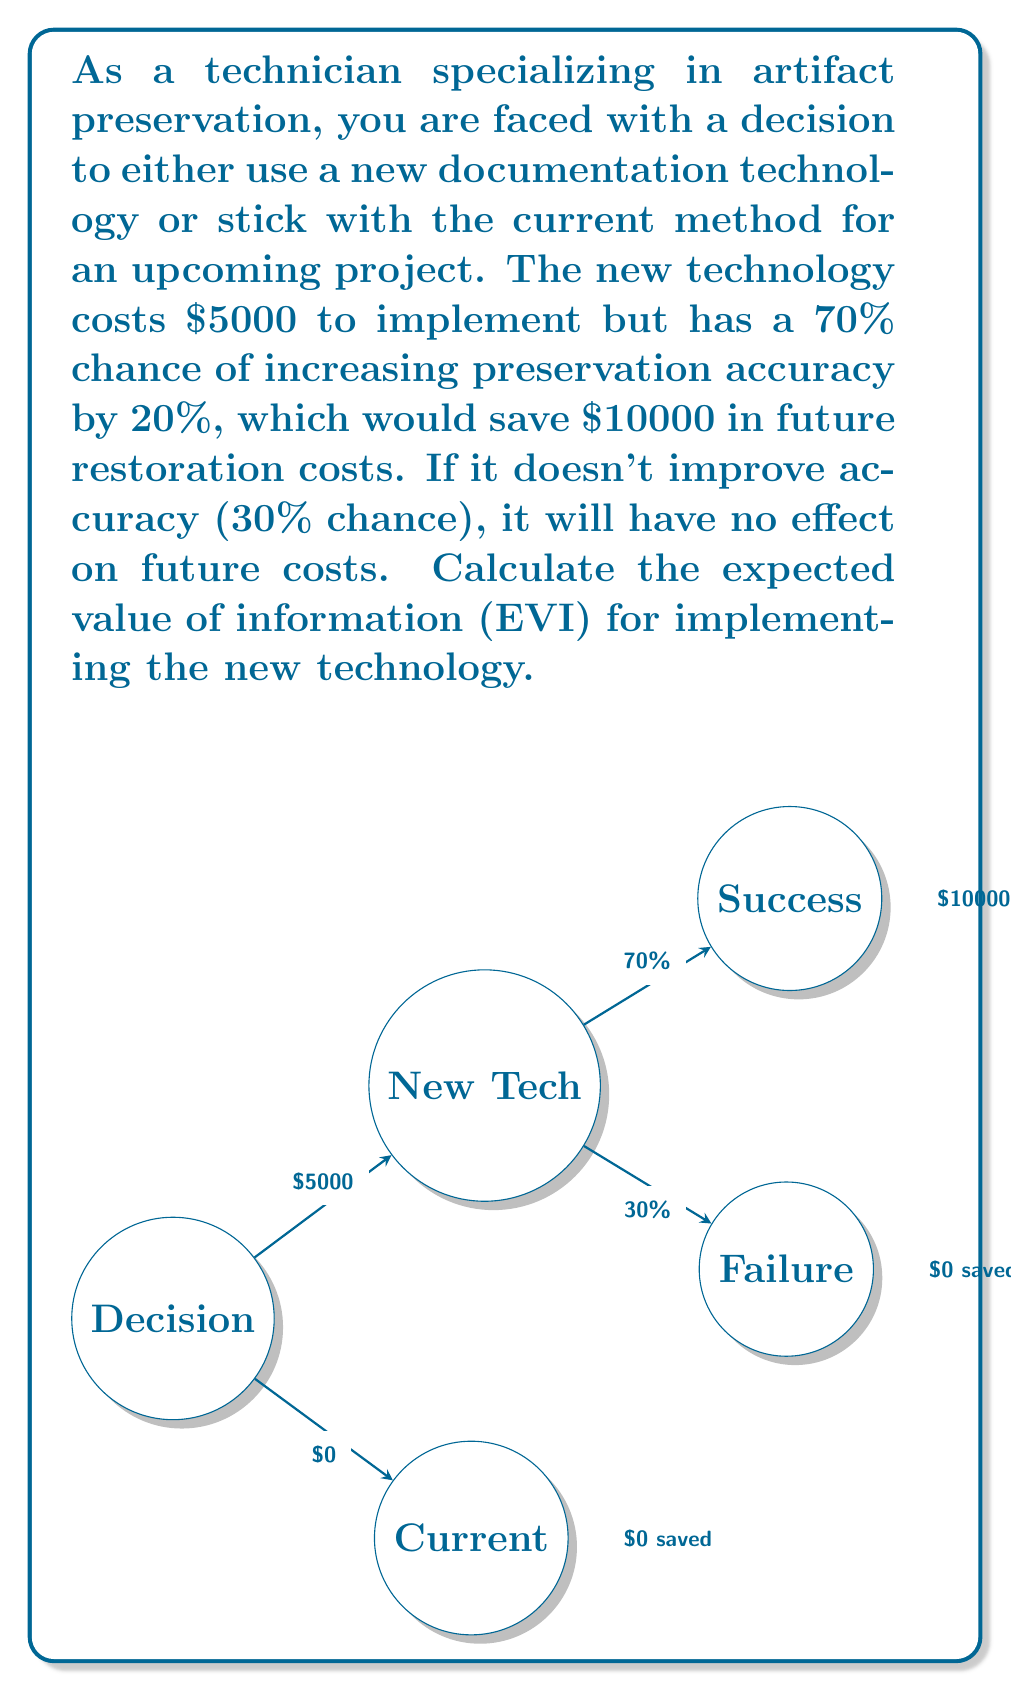Help me with this question. To calculate the Expected Value of Information (EVI), we need to follow these steps:

1) Calculate the expected value of implementing the new technology:
   $$EV_{new} = 0.7 \times (10000 - 5000) + 0.3 \times (-5000) = 2000$$

2) Calculate the expected value of sticking with the current method:
   $$EV_{current} = 0$$

3) The EVI is the difference between the expected value of the best decision with perfect information and the expected value of the best decision without this information:

   With perfect information:
   - If we knew it would succeed (70% chance): $10000 - 5000 = 5000$
   - If we knew it would fail (30% chance): $0$ (we wouldn't implement)
   
   Expected value with perfect information:
   $$EV_{perfect} = 0.7 \times 5000 + 0.3 \times 0 = 3500$$

4) Calculate EVI:
   $$EVI = EV_{perfect} - \max(EV_{new}, EV_{current}) = 3500 - 2000 = 1500$$

Therefore, the expected value of having perfect information about the success of the new technology is $1500.
Answer: $1500 